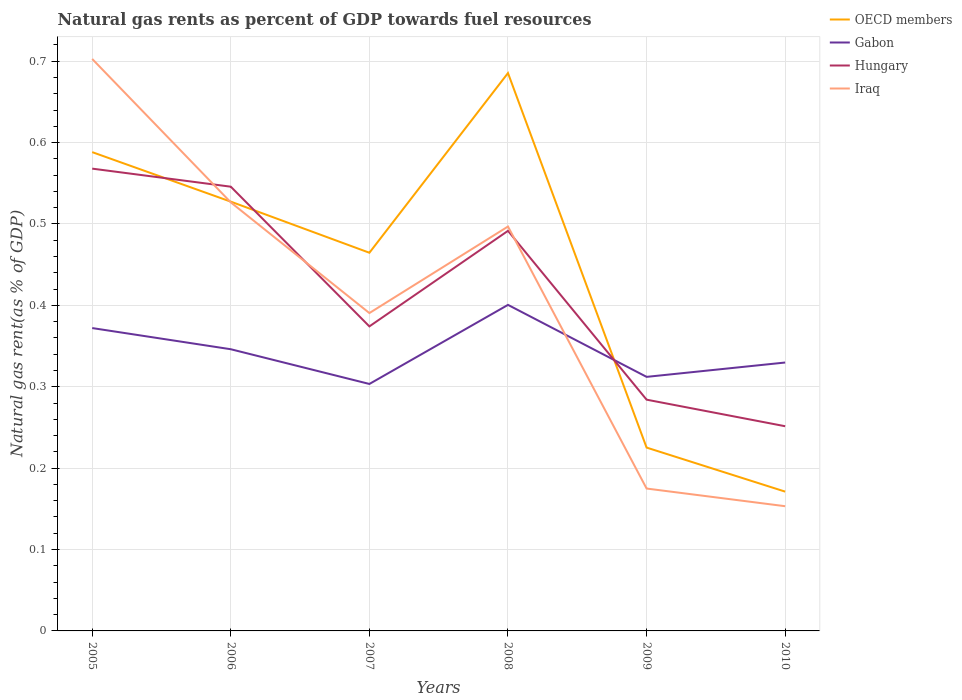How many different coloured lines are there?
Make the answer very short. 4. Is the number of lines equal to the number of legend labels?
Provide a short and direct response. Yes. Across all years, what is the maximum natural gas rent in Gabon?
Make the answer very short. 0.3. In which year was the natural gas rent in Gabon maximum?
Make the answer very short. 2007. What is the total natural gas rent in Gabon in the graph?
Offer a very short reply. 0.07. What is the difference between the highest and the second highest natural gas rent in Iraq?
Provide a succinct answer. 0.55. Is the natural gas rent in Hungary strictly greater than the natural gas rent in Iraq over the years?
Your answer should be compact. No. How many lines are there?
Make the answer very short. 4. How many years are there in the graph?
Your answer should be compact. 6. Are the values on the major ticks of Y-axis written in scientific E-notation?
Your answer should be compact. No. Does the graph contain any zero values?
Provide a succinct answer. No. Does the graph contain grids?
Offer a very short reply. Yes. What is the title of the graph?
Ensure brevity in your answer.  Natural gas rents as percent of GDP towards fuel resources. Does "Botswana" appear as one of the legend labels in the graph?
Make the answer very short. No. What is the label or title of the X-axis?
Your response must be concise. Years. What is the label or title of the Y-axis?
Give a very brief answer. Natural gas rent(as % of GDP). What is the Natural gas rent(as % of GDP) of OECD members in 2005?
Keep it short and to the point. 0.59. What is the Natural gas rent(as % of GDP) in Gabon in 2005?
Your response must be concise. 0.37. What is the Natural gas rent(as % of GDP) of Hungary in 2005?
Offer a very short reply. 0.57. What is the Natural gas rent(as % of GDP) in Iraq in 2005?
Provide a short and direct response. 0.7. What is the Natural gas rent(as % of GDP) of OECD members in 2006?
Give a very brief answer. 0.53. What is the Natural gas rent(as % of GDP) in Gabon in 2006?
Your response must be concise. 0.35. What is the Natural gas rent(as % of GDP) of Hungary in 2006?
Provide a short and direct response. 0.55. What is the Natural gas rent(as % of GDP) in Iraq in 2006?
Provide a short and direct response. 0.53. What is the Natural gas rent(as % of GDP) in OECD members in 2007?
Ensure brevity in your answer.  0.46. What is the Natural gas rent(as % of GDP) of Gabon in 2007?
Provide a short and direct response. 0.3. What is the Natural gas rent(as % of GDP) in Hungary in 2007?
Ensure brevity in your answer.  0.37. What is the Natural gas rent(as % of GDP) of Iraq in 2007?
Provide a succinct answer. 0.39. What is the Natural gas rent(as % of GDP) in OECD members in 2008?
Your response must be concise. 0.69. What is the Natural gas rent(as % of GDP) in Gabon in 2008?
Ensure brevity in your answer.  0.4. What is the Natural gas rent(as % of GDP) of Hungary in 2008?
Offer a terse response. 0.49. What is the Natural gas rent(as % of GDP) in Iraq in 2008?
Offer a very short reply. 0.5. What is the Natural gas rent(as % of GDP) of OECD members in 2009?
Your response must be concise. 0.23. What is the Natural gas rent(as % of GDP) in Gabon in 2009?
Provide a short and direct response. 0.31. What is the Natural gas rent(as % of GDP) of Hungary in 2009?
Offer a terse response. 0.28. What is the Natural gas rent(as % of GDP) in Iraq in 2009?
Provide a short and direct response. 0.17. What is the Natural gas rent(as % of GDP) in OECD members in 2010?
Your answer should be compact. 0.17. What is the Natural gas rent(as % of GDP) of Gabon in 2010?
Keep it short and to the point. 0.33. What is the Natural gas rent(as % of GDP) in Hungary in 2010?
Give a very brief answer. 0.25. What is the Natural gas rent(as % of GDP) of Iraq in 2010?
Your response must be concise. 0.15. Across all years, what is the maximum Natural gas rent(as % of GDP) of OECD members?
Your response must be concise. 0.69. Across all years, what is the maximum Natural gas rent(as % of GDP) of Gabon?
Offer a terse response. 0.4. Across all years, what is the maximum Natural gas rent(as % of GDP) in Hungary?
Offer a terse response. 0.57. Across all years, what is the maximum Natural gas rent(as % of GDP) of Iraq?
Your answer should be very brief. 0.7. Across all years, what is the minimum Natural gas rent(as % of GDP) in OECD members?
Provide a short and direct response. 0.17. Across all years, what is the minimum Natural gas rent(as % of GDP) in Gabon?
Provide a succinct answer. 0.3. Across all years, what is the minimum Natural gas rent(as % of GDP) of Hungary?
Provide a succinct answer. 0.25. Across all years, what is the minimum Natural gas rent(as % of GDP) of Iraq?
Make the answer very short. 0.15. What is the total Natural gas rent(as % of GDP) in OECD members in the graph?
Provide a succinct answer. 2.66. What is the total Natural gas rent(as % of GDP) in Gabon in the graph?
Ensure brevity in your answer.  2.06. What is the total Natural gas rent(as % of GDP) in Hungary in the graph?
Your answer should be very brief. 2.52. What is the total Natural gas rent(as % of GDP) in Iraq in the graph?
Ensure brevity in your answer.  2.44. What is the difference between the Natural gas rent(as % of GDP) in OECD members in 2005 and that in 2006?
Ensure brevity in your answer.  0.06. What is the difference between the Natural gas rent(as % of GDP) in Gabon in 2005 and that in 2006?
Give a very brief answer. 0.03. What is the difference between the Natural gas rent(as % of GDP) in Hungary in 2005 and that in 2006?
Ensure brevity in your answer.  0.02. What is the difference between the Natural gas rent(as % of GDP) of Iraq in 2005 and that in 2006?
Offer a terse response. 0.18. What is the difference between the Natural gas rent(as % of GDP) in OECD members in 2005 and that in 2007?
Offer a terse response. 0.12. What is the difference between the Natural gas rent(as % of GDP) of Gabon in 2005 and that in 2007?
Keep it short and to the point. 0.07. What is the difference between the Natural gas rent(as % of GDP) of Hungary in 2005 and that in 2007?
Keep it short and to the point. 0.19. What is the difference between the Natural gas rent(as % of GDP) in Iraq in 2005 and that in 2007?
Your response must be concise. 0.31. What is the difference between the Natural gas rent(as % of GDP) in OECD members in 2005 and that in 2008?
Offer a very short reply. -0.1. What is the difference between the Natural gas rent(as % of GDP) of Gabon in 2005 and that in 2008?
Give a very brief answer. -0.03. What is the difference between the Natural gas rent(as % of GDP) in Hungary in 2005 and that in 2008?
Make the answer very short. 0.08. What is the difference between the Natural gas rent(as % of GDP) of Iraq in 2005 and that in 2008?
Make the answer very short. 0.21. What is the difference between the Natural gas rent(as % of GDP) of OECD members in 2005 and that in 2009?
Your response must be concise. 0.36. What is the difference between the Natural gas rent(as % of GDP) in Hungary in 2005 and that in 2009?
Offer a very short reply. 0.28. What is the difference between the Natural gas rent(as % of GDP) of Iraq in 2005 and that in 2009?
Offer a terse response. 0.53. What is the difference between the Natural gas rent(as % of GDP) in OECD members in 2005 and that in 2010?
Offer a terse response. 0.42. What is the difference between the Natural gas rent(as % of GDP) of Gabon in 2005 and that in 2010?
Your response must be concise. 0.04. What is the difference between the Natural gas rent(as % of GDP) in Hungary in 2005 and that in 2010?
Make the answer very short. 0.32. What is the difference between the Natural gas rent(as % of GDP) of Iraq in 2005 and that in 2010?
Make the answer very short. 0.55. What is the difference between the Natural gas rent(as % of GDP) of OECD members in 2006 and that in 2007?
Your answer should be very brief. 0.06. What is the difference between the Natural gas rent(as % of GDP) of Gabon in 2006 and that in 2007?
Provide a succinct answer. 0.04. What is the difference between the Natural gas rent(as % of GDP) of Hungary in 2006 and that in 2007?
Provide a succinct answer. 0.17. What is the difference between the Natural gas rent(as % of GDP) in Iraq in 2006 and that in 2007?
Give a very brief answer. 0.14. What is the difference between the Natural gas rent(as % of GDP) in OECD members in 2006 and that in 2008?
Offer a terse response. -0.16. What is the difference between the Natural gas rent(as % of GDP) in Gabon in 2006 and that in 2008?
Keep it short and to the point. -0.05. What is the difference between the Natural gas rent(as % of GDP) of Hungary in 2006 and that in 2008?
Offer a terse response. 0.05. What is the difference between the Natural gas rent(as % of GDP) in Iraq in 2006 and that in 2008?
Give a very brief answer. 0.03. What is the difference between the Natural gas rent(as % of GDP) of OECD members in 2006 and that in 2009?
Offer a very short reply. 0.3. What is the difference between the Natural gas rent(as % of GDP) in Gabon in 2006 and that in 2009?
Give a very brief answer. 0.03. What is the difference between the Natural gas rent(as % of GDP) of Hungary in 2006 and that in 2009?
Offer a very short reply. 0.26. What is the difference between the Natural gas rent(as % of GDP) of Iraq in 2006 and that in 2009?
Ensure brevity in your answer.  0.35. What is the difference between the Natural gas rent(as % of GDP) in OECD members in 2006 and that in 2010?
Ensure brevity in your answer.  0.36. What is the difference between the Natural gas rent(as % of GDP) of Gabon in 2006 and that in 2010?
Your answer should be very brief. 0.02. What is the difference between the Natural gas rent(as % of GDP) in Hungary in 2006 and that in 2010?
Provide a short and direct response. 0.29. What is the difference between the Natural gas rent(as % of GDP) in Iraq in 2006 and that in 2010?
Your response must be concise. 0.37. What is the difference between the Natural gas rent(as % of GDP) of OECD members in 2007 and that in 2008?
Your response must be concise. -0.22. What is the difference between the Natural gas rent(as % of GDP) of Gabon in 2007 and that in 2008?
Give a very brief answer. -0.1. What is the difference between the Natural gas rent(as % of GDP) in Hungary in 2007 and that in 2008?
Provide a succinct answer. -0.12. What is the difference between the Natural gas rent(as % of GDP) of Iraq in 2007 and that in 2008?
Your answer should be compact. -0.11. What is the difference between the Natural gas rent(as % of GDP) in OECD members in 2007 and that in 2009?
Provide a succinct answer. 0.24. What is the difference between the Natural gas rent(as % of GDP) of Gabon in 2007 and that in 2009?
Your answer should be compact. -0.01. What is the difference between the Natural gas rent(as % of GDP) in Hungary in 2007 and that in 2009?
Offer a terse response. 0.09. What is the difference between the Natural gas rent(as % of GDP) in Iraq in 2007 and that in 2009?
Provide a short and direct response. 0.22. What is the difference between the Natural gas rent(as % of GDP) of OECD members in 2007 and that in 2010?
Ensure brevity in your answer.  0.29. What is the difference between the Natural gas rent(as % of GDP) in Gabon in 2007 and that in 2010?
Your response must be concise. -0.03. What is the difference between the Natural gas rent(as % of GDP) in Hungary in 2007 and that in 2010?
Keep it short and to the point. 0.12. What is the difference between the Natural gas rent(as % of GDP) of Iraq in 2007 and that in 2010?
Give a very brief answer. 0.24. What is the difference between the Natural gas rent(as % of GDP) in OECD members in 2008 and that in 2009?
Provide a succinct answer. 0.46. What is the difference between the Natural gas rent(as % of GDP) of Gabon in 2008 and that in 2009?
Your answer should be compact. 0.09. What is the difference between the Natural gas rent(as % of GDP) in Hungary in 2008 and that in 2009?
Make the answer very short. 0.21. What is the difference between the Natural gas rent(as % of GDP) of Iraq in 2008 and that in 2009?
Give a very brief answer. 0.32. What is the difference between the Natural gas rent(as % of GDP) of OECD members in 2008 and that in 2010?
Offer a very short reply. 0.51. What is the difference between the Natural gas rent(as % of GDP) of Gabon in 2008 and that in 2010?
Make the answer very short. 0.07. What is the difference between the Natural gas rent(as % of GDP) in Hungary in 2008 and that in 2010?
Your response must be concise. 0.24. What is the difference between the Natural gas rent(as % of GDP) of Iraq in 2008 and that in 2010?
Your response must be concise. 0.34. What is the difference between the Natural gas rent(as % of GDP) in OECD members in 2009 and that in 2010?
Make the answer very short. 0.05. What is the difference between the Natural gas rent(as % of GDP) of Gabon in 2009 and that in 2010?
Keep it short and to the point. -0.02. What is the difference between the Natural gas rent(as % of GDP) in Hungary in 2009 and that in 2010?
Your response must be concise. 0.03. What is the difference between the Natural gas rent(as % of GDP) of Iraq in 2009 and that in 2010?
Offer a terse response. 0.02. What is the difference between the Natural gas rent(as % of GDP) in OECD members in 2005 and the Natural gas rent(as % of GDP) in Gabon in 2006?
Give a very brief answer. 0.24. What is the difference between the Natural gas rent(as % of GDP) of OECD members in 2005 and the Natural gas rent(as % of GDP) of Hungary in 2006?
Provide a short and direct response. 0.04. What is the difference between the Natural gas rent(as % of GDP) of OECD members in 2005 and the Natural gas rent(as % of GDP) of Iraq in 2006?
Ensure brevity in your answer.  0.06. What is the difference between the Natural gas rent(as % of GDP) of Gabon in 2005 and the Natural gas rent(as % of GDP) of Hungary in 2006?
Your answer should be very brief. -0.17. What is the difference between the Natural gas rent(as % of GDP) of Gabon in 2005 and the Natural gas rent(as % of GDP) of Iraq in 2006?
Offer a terse response. -0.15. What is the difference between the Natural gas rent(as % of GDP) in Hungary in 2005 and the Natural gas rent(as % of GDP) in Iraq in 2006?
Ensure brevity in your answer.  0.04. What is the difference between the Natural gas rent(as % of GDP) in OECD members in 2005 and the Natural gas rent(as % of GDP) in Gabon in 2007?
Give a very brief answer. 0.28. What is the difference between the Natural gas rent(as % of GDP) of OECD members in 2005 and the Natural gas rent(as % of GDP) of Hungary in 2007?
Provide a succinct answer. 0.21. What is the difference between the Natural gas rent(as % of GDP) in OECD members in 2005 and the Natural gas rent(as % of GDP) in Iraq in 2007?
Provide a succinct answer. 0.2. What is the difference between the Natural gas rent(as % of GDP) of Gabon in 2005 and the Natural gas rent(as % of GDP) of Hungary in 2007?
Ensure brevity in your answer.  -0. What is the difference between the Natural gas rent(as % of GDP) of Gabon in 2005 and the Natural gas rent(as % of GDP) of Iraq in 2007?
Provide a succinct answer. -0.02. What is the difference between the Natural gas rent(as % of GDP) of Hungary in 2005 and the Natural gas rent(as % of GDP) of Iraq in 2007?
Provide a short and direct response. 0.18. What is the difference between the Natural gas rent(as % of GDP) in OECD members in 2005 and the Natural gas rent(as % of GDP) in Gabon in 2008?
Your answer should be compact. 0.19. What is the difference between the Natural gas rent(as % of GDP) in OECD members in 2005 and the Natural gas rent(as % of GDP) in Hungary in 2008?
Your response must be concise. 0.1. What is the difference between the Natural gas rent(as % of GDP) in OECD members in 2005 and the Natural gas rent(as % of GDP) in Iraq in 2008?
Provide a succinct answer. 0.09. What is the difference between the Natural gas rent(as % of GDP) in Gabon in 2005 and the Natural gas rent(as % of GDP) in Hungary in 2008?
Your response must be concise. -0.12. What is the difference between the Natural gas rent(as % of GDP) of Gabon in 2005 and the Natural gas rent(as % of GDP) of Iraq in 2008?
Your answer should be very brief. -0.12. What is the difference between the Natural gas rent(as % of GDP) of Hungary in 2005 and the Natural gas rent(as % of GDP) of Iraq in 2008?
Keep it short and to the point. 0.07. What is the difference between the Natural gas rent(as % of GDP) of OECD members in 2005 and the Natural gas rent(as % of GDP) of Gabon in 2009?
Keep it short and to the point. 0.28. What is the difference between the Natural gas rent(as % of GDP) in OECD members in 2005 and the Natural gas rent(as % of GDP) in Hungary in 2009?
Ensure brevity in your answer.  0.3. What is the difference between the Natural gas rent(as % of GDP) of OECD members in 2005 and the Natural gas rent(as % of GDP) of Iraq in 2009?
Your answer should be very brief. 0.41. What is the difference between the Natural gas rent(as % of GDP) of Gabon in 2005 and the Natural gas rent(as % of GDP) of Hungary in 2009?
Your response must be concise. 0.09. What is the difference between the Natural gas rent(as % of GDP) of Gabon in 2005 and the Natural gas rent(as % of GDP) of Iraq in 2009?
Your answer should be very brief. 0.2. What is the difference between the Natural gas rent(as % of GDP) of Hungary in 2005 and the Natural gas rent(as % of GDP) of Iraq in 2009?
Make the answer very short. 0.39. What is the difference between the Natural gas rent(as % of GDP) in OECD members in 2005 and the Natural gas rent(as % of GDP) in Gabon in 2010?
Make the answer very short. 0.26. What is the difference between the Natural gas rent(as % of GDP) of OECD members in 2005 and the Natural gas rent(as % of GDP) of Hungary in 2010?
Your answer should be very brief. 0.34. What is the difference between the Natural gas rent(as % of GDP) in OECD members in 2005 and the Natural gas rent(as % of GDP) in Iraq in 2010?
Provide a short and direct response. 0.43. What is the difference between the Natural gas rent(as % of GDP) of Gabon in 2005 and the Natural gas rent(as % of GDP) of Hungary in 2010?
Keep it short and to the point. 0.12. What is the difference between the Natural gas rent(as % of GDP) of Gabon in 2005 and the Natural gas rent(as % of GDP) of Iraq in 2010?
Your answer should be very brief. 0.22. What is the difference between the Natural gas rent(as % of GDP) of Hungary in 2005 and the Natural gas rent(as % of GDP) of Iraq in 2010?
Keep it short and to the point. 0.41. What is the difference between the Natural gas rent(as % of GDP) of OECD members in 2006 and the Natural gas rent(as % of GDP) of Gabon in 2007?
Ensure brevity in your answer.  0.22. What is the difference between the Natural gas rent(as % of GDP) of OECD members in 2006 and the Natural gas rent(as % of GDP) of Hungary in 2007?
Your answer should be very brief. 0.15. What is the difference between the Natural gas rent(as % of GDP) in OECD members in 2006 and the Natural gas rent(as % of GDP) in Iraq in 2007?
Give a very brief answer. 0.14. What is the difference between the Natural gas rent(as % of GDP) in Gabon in 2006 and the Natural gas rent(as % of GDP) in Hungary in 2007?
Your answer should be compact. -0.03. What is the difference between the Natural gas rent(as % of GDP) of Gabon in 2006 and the Natural gas rent(as % of GDP) of Iraq in 2007?
Make the answer very short. -0.04. What is the difference between the Natural gas rent(as % of GDP) in Hungary in 2006 and the Natural gas rent(as % of GDP) in Iraq in 2007?
Give a very brief answer. 0.16. What is the difference between the Natural gas rent(as % of GDP) in OECD members in 2006 and the Natural gas rent(as % of GDP) in Gabon in 2008?
Ensure brevity in your answer.  0.13. What is the difference between the Natural gas rent(as % of GDP) of OECD members in 2006 and the Natural gas rent(as % of GDP) of Hungary in 2008?
Keep it short and to the point. 0.04. What is the difference between the Natural gas rent(as % of GDP) in OECD members in 2006 and the Natural gas rent(as % of GDP) in Iraq in 2008?
Provide a succinct answer. 0.03. What is the difference between the Natural gas rent(as % of GDP) of Gabon in 2006 and the Natural gas rent(as % of GDP) of Hungary in 2008?
Keep it short and to the point. -0.15. What is the difference between the Natural gas rent(as % of GDP) in Gabon in 2006 and the Natural gas rent(as % of GDP) in Iraq in 2008?
Keep it short and to the point. -0.15. What is the difference between the Natural gas rent(as % of GDP) of Hungary in 2006 and the Natural gas rent(as % of GDP) of Iraq in 2008?
Provide a short and direct response. 0.05. What is the difference between the Natural gas rent(as % of GDP) in OECD members in 2006 and the Natural gas rent(as % of GDP) in Gabon in 2009?
Offer a terse response. 0.22. What is the difference between the Natural gas rent(as % of GDP) in OECD members in 2006 and the Natural gas rent(as % of GDP) in Hungary in 2009?
Keep it short and to the point. 0.24. What is the difference between the Natural gas rent(as % of GDP) in OECD members in 2006 and the Natural gas rent(as % of GDP) in Iraq in 2009?
Give a very brief answer. 0.35. What is the difference between the Natural gas rent(as % of GDP) of Gabon in 2006 and the Natural gas rent(as % of GDP) of Hungary in 2009?
Provide a short and direct response. 0.06. What is the difference between the Natural gas rent(as % of GDP) of Gabon in 2006 and the Natural gas rent(as % of GDP) of Iraq in 2009?
Your answer should be compact. 0.17. What is the difference between the Natural gas rent(as % of GDP) in Hungary in 2006 and the Natural gas rent(as % of GDP) in Iraq in 2009?
Give a very brief answer. 0.37. What is the difference between the Natural gas rent(as % of GDP) of OECD members in 2006 and the Natural gas rent(as % of GDP) of Gabon in 2010?
Give a very brief answer. 0.2. What is the difference between the Natural gas rent(as % of GDP) in OECD members in 2006 and the Natural gas rent(as % of GDP) in Hungary in 2010?
Your answer should be compact. 0.28. What is the difference between the Natural gas rent(as % of GDP) of OECD members in 2006 and the Natural gas rent(as % of GDP) of Iraq in 2010?
Offer a terse response. 0.37. What is the difference between the Natural gas rent(as % of GDP) of Gabon in 2006 and the Natural gas rent(as % of GDP) of Hungary in 2010?
Provide a succinct answer. 0.09. What is the difference between the Natural gas rent(as % of GDP) in Gabon in 2006 and the Natural gas rent(as % of GDP) in Iraq in 2010?
Your response must be concise. 0.19. What is the difference between the Natural gas rent(as % of GDP) in Hungary in 2006 and the Natural gas rent(as % of GDP) in Iraq in 2010?
Provide a succinct answer. 0.39. What is the difference between the Natural gas rent(as % of GDP) of OECD members in 2007 and the Natural gas rent(as % of GDP) of Gabon in 2008?
Make the answer very short. 0.06. What is the difference between the Natural gas rent(as % of GDP) of OECD members in 2007 and the Natural gas rent(as % of GDP) of Hungary in 2008?
Provide a succinct answer. -0.03. What is the difference between the Natural gas rent(as % of GDP) in OECD members in 2007 and the Natural gas rent(as % of GDP) in Iraq in 2008?
Give a very brief answer. -0.03. What is the difference between the Natural gas rent(as % of GDP) in Gabon in 2007 and the Natural gas rent(as % of GDP) in Hungary in 2008?
Provide a succinct answer. -0.19. What is the difference between the Natural gas rent(as % of GDP) of Gabon in 2007 and the Natural gas rent(as % of GDP) of Iraq in 2008?
Keep it short and to the point. -0.19. What is the difference between the Natural gas rent(as % of GDP) in Hungary in 2007 and the Natural gas rent(as % of GDP) in Iraq in 2008?
Your answer should be compact. -0.12. What is the difference between the Natural gas rent(as % of GDP) of OECD members in 2007 and the Natural gas rent(as % of GDP) of Gabon in 2009?
Your answer should be compact. 0.15. What is the difference between the Natural gas rent(as % of GDP) of OECD members in 2007 and the Natural gas rent(as % of GDP) of Hungary in 2009?
Offer a very short reply. 0.18. What is the difference between the Natural gas rent(as % of GDP) in OECD members in 2007 and the Natural gas rent(as % of GDP) in Iraq in 2009?
Provide a short and direct response. 0.29. What is the difference between the Natural gas rent(as % of GDP) of Gabon in 2007 and the Natural gas rent(as % of GDP) of Hungary in 2009?
Give a very brief answer. 0.02. What is the difference between the Natural gas rent(as % of GDP) in Gabon in 2007 and the Natural gas rent(as % of GDP) in Iraq in 2009?
Provide a succinct answer. 0.13. What is the difference between the Natural gas rent(as % of GDP) in Hungary in 2007 and the Natural gas rent(as % of GDP) in Iraq in 2009?
Provide a succinct answer. 0.2. What is the difference between the Natural gas rent(as % of GDP) in OECD members in 2007 and the Natural gas rent(as % of GDP) in Gabon in 2010?
Your answer should be compact. 0.13. What is the difference between the Natural gas rent(as % of GDP) in OECD members in 2007 and the Natural gas rent(as % of GDP) in Hungary in 2010?
Give a very brief answer. 0.21. What is the difference between the Natural gas rent(as % of GDP) in OECD members in 2007 and the Natural gas rent(as % of GDP) in Iraq in 2010?
Your answer should be compact. 0.31. What is the difference between the Natural gas rent(as % of GDP) in Gabon in 2007 and the Natural gas rent(as % of GDP) in Hungary in 2010?
Give a very brief answer. 0.05. What is the difference between the Natural gas rent(as % of GDP) in Gabon in 2007 and the Natural gas rent(as % of GDP) in Iraq in 2010?
Offer a terse response. 0.15. What is the difference between the Natural gas rent(as % of GDP) in Hungary in 2007 and the Natural gas rent(as % of GDP) in Iraq in 2010?
Your response must be concise. 0.22. What is the difference between the Natural gas rent(as % of GDP) in OECD members in 2008 and the Natural gas rent(as % of GDP) in Gabon in 2009?
Ensure brevity in your answer.  0.37. What is the difference between the Natural gas rent(as % of GDP) in OECD members in 2008 and the Natural gas rent(as % of GDP) in Hungary in 2009?
Keep it short and to the point. 0.4. What is the difference between the Natural gas rent(as % of GDP) of OECD members in 2008 and the Natural gas rent(as % of GDP) of Iraq in 2009?
Your answer should be very brief. 0.51. What is the difference between the Natural gas rent(as % of GDP) of Gabon in 2008 and the Natural gas rent(as % of GDP) of Hungary in 2009?
Offer a very short reply. 0.12. What is the difference between the Natural gas rent(as % of GDP) of Gabon in 2008 and the Natural gas rent(as % of GDP) of Iraq in 2009?
Provide a succinct answer. 0.23. What is the difference between the Natural gas rent(as % of GDP) in Hungary in 2008 and the Natural gas rent(as % of GDP) in Iraq in 2009?
Your answer should be compact. 0.32. What is the difference between the Natural gas rent(as % of GDP) in OECD members in 2008 and the Natural gas rent(as % of GDP) in Gabon in 2010?
Your response must be concise. 0.36. What is the difference between the Natural gas rent(as % of GDP) of OECD members in 2008 and the Natural gas rent(as % of GDP) of Hungary in 2010?
Offer a very short reply. 0.43. What is the difference between the Natural gas rent(as % of GDP) in OECD members in 2008 and the Natural gas rent(as % of GDP) in Iraq in 2010?
Provide a short and direct response. 0.53. What is the difference between the Natural gas rent(as % of GDP) of Gabon in 2008 and the Natural gas rent(as % of GDP) of Hungary in 2010?
Offer a terse response. 0.15. What is the difference between the Natural gas rent(as % of GDP) of Gabon in 2008 and the Natural gas rent(as % of GDP) of Iraq in 2010?
Provide a succinct answer. 0.25. What is the difference between the Natural gas rent(as % of GDP) of Hungary in 2008 and the Natural gas rent(as % of GDP) of Iraq in 2010?
Offer a terse response. 0.34. What is the difference between the Natural gas rent(as % of GDP) in OECD members in 2009 and the Natural gas rent(as % of GDP) in Gabon in 2010?
Ensure brevity in your answer.  -0.1. What is the difference between the Natural gas rent(as % of GDP) in OECD members in 2009 and the Natural gas rent(as % of GDP) in Hungary in 2010?
Your response must be concise. -0.03. What is the difference between the Natural gas rent(as % of GDP) of OECD members in 2009 and the Natural gas rent(as % of GDP) of Iraq in 2010?
Your answer should be very brief. 0.07. What is the difference between the Natural gas rent(as % of GDP) in Gabon in 2009 and the Natural gas rent(as % of GDP) in Hungary in 2010?
Your answer should be very brief. 0.06. What is the difference between the Natural gas rent(as % of GDP) of Gabon in 2009 and the Natural gas rent(as % of GDP) of Iraq in 2010?
Keep it short and to the point. 0.16. What is the difference between the Natural gas rent(as % of GDP) in Hungary in 2009 and the Natural gas rent(as % of GDP) in Iraq in 2010?
Give a very brief answer. 0.13. What is the average Natural gas rent(as % of GDP) of OECD members per year?
Provide a short and direct response. 0.44. What is the average Natural gas rent(as % of GDP) in Gabon per year?
Ensure brevity in your answer.  0.34. What is the average Natural gas rent(as % of GDP) in Hungary per year?
Make the answer very short. 0.42. What is the average Natural gas rent(as % of GDP) in Iraq per year?
Make the answer very short. 0.41. In the year 2005, what is the difference between the Natural gas rent(as % of GDP) of OECD members and Natural gas rent(as % of GDP) of Gabon?
Offer a very short reply. 0.22. In the year 2005, what is the difference between the Natural gas rent(as % of GDP) in OECD members and Natural gas rent(as % of GDP) in Hungary?
Your answer should be very brief. 0.02. In the year 2005, what is the difference between the Natural gas rent(as % of GDP) of OECD members and Natural gas rent(as % of GDP) of Iraq?
Keep it short and to the point. -0.11. In the year 2005, what is the difference between the Natural gas rent(as % of GDP) of Gabon and Natural gas rent(as % of GDP) of Hungary?
Ensure brevity in your answer.  -0.2. In the year 2005, what is the difference between the Natural gas rent(as % of GDP) of Gabon and Natural gas rent(as % of GDP) of Iraq?
Offer a very short reply. -0.33. In the year 2005, what is the difference between the Natural gas rent(as % of GDP) of Hungary and Natural gas rent(as % of GDP) of Iraq?
Make the answer very short. -0.13. In the year 2006, what is the difference between the Natural gas rent(as % of GDP) in OECD members and Natural gas rent(as % of GDP) in Gabon?
Your answer should be compact. 0.18. In the year 2006, what is the difference between the Natural gas rent(as % of GDP) of OECD members and Natural gas rent(as % of GDP) of Hungary?
Your answer should be compact. -0.02. In the year 2006, what is the difference between the Natural gas rent(as % of GDP) in OECD members and Natural gas rent(as % of GDP) in Iraq?
Make the answer very short. 0. In the year 2006, what is the difference between the Natural gas rent(as % of GDP) in Gabon and Natural gas rent(as % of GDP) in Hungary?
Keep it short and to the point. -0.2. In the year 2006, what is the difference between the Natural gas rent(as % of GDP) in Gabon and Natural gas rent(as % of GDP) in Iraq?
Provide a succinct answer. -0.18. In the year 2006, what is the difference between the Natural gas rent(as % of GDP) of Hungary and Natural gas rent(as % of GDP) of Iraq?
Offer a terse response. 0.02. In the year 2007, what is the difference between the Natural gas rent(as % of GDP) of OECD members and Natural gas rent(as % of GDP) of Gabon?
Your response must be concise. 0.16. In the year 2007, what is the difference between the Natural gas rent(as % of GDP) of OECD members and Natural gas rent(as % of GDP) of Hungary?
Your answer should be compact. 0.09. In the year 2007, what is the difference between the Natural gas rent(as % of GDP) in OECD members and Natural gas rent(as % of GDP) in Iraq?
Keep it short and to the point. 0.07. In the year 2007, what is the difference between the Natural gas rent(as % of GDP) in Gabon and Natural gas rent(as % of GDP) in Hungary?
Offer a very short reply. -0.07. In the year 2007, what is the difference between the Natural gas rent(as % of GDP) of Gabon and Natural gas rent(as % of GDP) of Iraq?
Offer a very short reply. -0.09. In the year 2007, what is the difference between the Natural gas rent(as % of GDP) of Hungary and Natural gas rent(as % of GDP) of Iraq?
Keep it short and to the point. -0.02. In the year 2008, what is the difference between the Natural gas rent(as % of GDP) of OECD members and Natural gas rent(as % of GDP) of Gabon?
Your answer should be very brief. 0.28. In the year 2008, what is the difference between the Natural gas rent(as % of GDP) of OECD members and Natural gas rent(as % of GDP) of Hungary?
Provide a short and direct response. 0.19. In the year 2008, what is the difference between the Natural gas rent(as % of GDP) in OECD members and Natural gas rent(as % of GDP) in Iraq?
Make the answer very short. 0.19. In the year 2008, what is the difference between the Natural gas rent(as % of GDP) in Gabon and Natural gas rent(as % of GDP) in Hungary?
Give a very brief answer. -0.09. In the year 2008, what is the difference between the Natural gas rent(as % of GDP) of Gabon and Natural gas rent(as % of GDP) of Iraq?
Keep it short and to the point. -0.1. In the year 2008, what is the difference between the Natural gas rent(as % of GDP) in Hungary and Natural gas rent(as % of GDP) in Iraq?
Provide a short and direct response. -0.01. In the year 2009, what is the difference between the Natural gas rent(as % of GDP) of OECD members and Natural gas rent(as % of GDP) of Gabon?
Your answer should be very brief. -0.09. In the year 2009, what is the difference between the Natural gas rent(as % of GDP) of OECD members and Natural gas rent(as % of GDP) of Hungary?
Ensure brevity in your answer.  -0.06. In the year 2009, what is the difference between the Natural gas rent(as % of GDP) of OECD members and Natural gas rent(as % of GDP) of Iraq?
Provide a succinct answer. 0.05. In the year 2009, what is the difference between the Natural gas rent(as % of GDP) of Gabon and Natural gas rent(as % of GDP) of Hungary?
Your answer should be compact. 0.03. In the year 2009, what is the difference between the Natural gas rent(as % of GDP) in Gabon and Natural gas rent(as % of GDP) in Iraq?
Give a very brief answer. 0.14. In the year 2009, what is the difference between the Natural gas rent(as % of GDP) of Hungary and Natural gas rent(as % of GDP) of Iraq?
Offer a terse response. 0.11. In the year 2010, what is the difference between the Natural gas rent(as % of GDP) in OECD members and Natural gas rent(as % of GDP) in Gabon?
Offer a terse response. -0.16. In the year 2010, what is the difference between the Natural gas rent(as % of GDP) of OECD members and Natural gas rent(as % of GDP) of Hungary?
Your answer should be compact. -0.08. In the year 2010, what is the difference between the Natural gas rent(as % of GDP) of OECD members and Natural gas rent(as % of GDP) of Iraq?
Your answer should be very brief. 0.02. In the year 2010, what is the difference between the Natural gas rent(as % of GDP) in Gabon and Natural gas rent(as % of GDP) in Hungary?
Provide a succinct answer. 0.08. In the year 2010, what is the difference between the Natural gas rent(as % of GDP) in Gabon and Natural gas rent(as % of GDP) in Iraq?
Provide a short and direct response. 0.18. In the year 2010, what is the difference between the Natural gas rent(as % of GDP) of Hungary and Natural gas rent(as % of GDP) of Iraq?
Provide a succinct answer. 0.1. What is the ratio of the Natural gas rent(as % of GDP) in OECD members in 2005 to that in 2006?
Offer a terse response. 1.12. What is the ratio of the Natural gas rent(as % of GDP) in Gabon in 2005 to that in 2006?
Provide a succinct answer. 1.08. What is the ratio of the Natural gas rent(as % of GDP) of Hungary in 2005 to that in 2006?
Your response must be concise. 1.04. What is the ratio of the Natural gas rent(as % of GDP) of Iraq in 2005 to that in 2006?
Offer a terse response. 1.33. What is the ratio of the Natural gas rent(as % of GDP) of OECD members in 2005 to that in 2007?
Give a very brief answer. 1.27. What is the ratio of the Natural gas rent(as % of GDP) in Gabon in 2005 to that in 2007?
Offer a very short reply. 1.23. What is the ratio of the Natural gas rent(as % of GDP) of Hungary in 2005 to that in 2007?
Offer a very short reply. 1.52. What is the ratio of the Natural gas rent(as % of GDP) of Iraq in 2005 to that in 2007?
Offer a terse response. 1.8. What is the ratio of the Natural gas rent(as % of GDP) in OECD members in 2005 to that in 2008?
Ensure brevity in your answer.  0.86. What is the ratio of the Natural gas rent(as % of GDP) in Gabon in 2005 to that in 2008?
Your answer should be compact. 0.93. What is the ratio of the Natural gas rent(as % of GDP) of Hungary in 2005 to that in 2008?
Ensure brevity in your answer.  1.16. What is the ratio of the Natural gas rent(as % of GDP) of Iraq in 2005 to that in 2008?
Keep it short and to the point. 1.41. What is the ratio of the Natural gas rent(as % of GDP) in OECD members in 2005 to that in 2009?
Provide a succinct answer. 2.61. What is the ratio of the Natural gas rent(as % of GDP) of Gabon in 2005 to that in 2009?
Your response must be concise. 1.19. What is the ratio of the Natural gas rent(as % of GDP) in Hungary in 2005 to that in 2009?
Keep it short and to the point. 2. What is the ratio of the Natural gas rent(as % of GDP) of Iraq in 2005 to that in 2009?
Make the answer very short. 4.02. What is the ratio of the Natural gas rent(as % of GDP) in OECD members in 2005 to that in 2010?
Ensure brevity in your answer.  3.44. What is the ratio of the Natural gas rent(as % of GDP) of Gabon in 2005 to that in 2010?
Your answer should be compact. 1.13. What is the ratio of the Natural gas rent(as % of GDP) in Hungary in 2005 to that in 2010?
Offer a terse response. 2.26. What is the ratio of the Natural gas rent(as % of GDP) in Iraq in 2005 to that in 2010?
Keep it short and to the point. 4.59. What is the ratio of the Natural gas rent(as % of GDP) of OECD members in 2006 to that in 2007?
Provide a short and direct response. 1.14. What is the ratio of the Natural gas rent(as % of GDP) of Gabon in 2006 to that in 2007?
Provide a succinct answer. 1.14. What is the ratio of the Natural gas rent(as % of GDP) of Hungary in 2006 to that in 2007?
Provide a succinct answer. 1.46. What is the ratio of the Natural gas rent(as % of GDP) of Iraq in 2006 to that in 2007?
Your answer should be compact. 1.35. What is the ratio of the Natural gas rent(as % of GDP) in OECD members in 2006 to that in 2008?
Your response must be concise. 0.77. What is the ratio of the Natural gas rent(as % of GDP) of Gabon in 2006 to that in 2008?
Your answer should be very brief. 0.86. What is the ratio of the Natural gas rent(as % of GDP) in Hungary in 2006 to that in 2008?
Offer a terse response. 1.11. What is the ratio of the Natural gas rent(as % of GDP) of Iraq in 2006 to that in 2008?
Provide a short and direct response. 1.06. What is the ratio of the Natural gas rent(as % of GDP) of OECD members in 2006 to that in 2009?
Your response must be concise. 2.34. What is the ratio of the Natural gas rent(as % of GDP) of Gabon in 2006 to that in 2009?
Ensure brevity in your answer.  1.11. What is the ratio of the Natural gas rent(as % of GDP) of Hungary in 2006 to that in 2009?
Your response must be concise. 1.92. What is the ratio of the Natural gas rent(as % of GDP) in Iraq in 2006 to that in 2009?
Your answer should be compact. 3.01. What is the ratio of the Natural gas rent(as % of GDP) of OECD members in 2006 to that in 2010?
Your answer should be very brief. 3.08. What is the ratio of the Natural gas rent(as % of GDP) of Gabon in 2006 to that in 2010?
Make the answer very short. 1.05. What is the ratio of the Natural gas rent(as % of GDP) of Hungary in 2006 to that in 2010?
Provide a short and direct response. 2.17. What is the ratio of the Natural gas rent(as % of GDP) in Iraq in 2006 to that in 2010?
Provide a succinct answer. 3.44. What is the ratio of the Natural gas rent(as % of GDP) of OECD members in 2007 to that in 2008?
Ensure brevity in your answer.  0.68. What is the ratio of the Natural gas rent(as % of GDP) of Gabon in 2007 to that in 2008?
Provide a short and direct response. 0.76. What is the ratio of the Natural gas rent(as % of GDP) in Hungary in 2007 to that in 2008?
Your answer should be compact. 0.76. What is the ratio of the Natural gas rent(as % of GDP) of Iraq in 2007 to that in 2008?
Offer a terse response. 0.79. What is the ratio of the Natural gas rent(as % of GDP) in OECD members in 2007 to that in 2009?
Provide a short and direct response. 2.06. What is the ratio of the Natural gas rent(as % of GDP) of Gabon in 2007 to that in 2009?
Ensure brevity in your answer.  0.97. What is the ratio of the Natural gas rent(as % of GDP) of Hungary in 2007 to that in 2009?
Offer a terse response. 1.32. What is the ratio of the Natural gas rent(as % of GDP) of Iraq in 2007 to that in 2009?
Make the answer very short. 2.23. What is the ratio of the Natural gas rent(as % of GDP) of OECD members in 2007 to that in 2010?
Keep it short and to the point. 2.71. What is the ratio of the Natural gas rent(as % of GDP) in Gabon in 2007 to that in 2010?
Your answer should be compact. 0.92. What is the ratio of the Natural gas rent(as % of GDP) of Hungary in 2007 to that in 2010?
Make the answer very short. 1.49. What is the ratio of the Natural gas rent(as % of GDP) of Iraq in 2007 to that in 2010?
Provide a short and direct response. 2.55. What is the ratio of the Natural gas rent(as % of GDP) in OECD members in 2008 to that in 2009?
Ensure brevity in your answer.  3.04. What is the ratio of the Natural gas rent(as % of GDP) in Gabon in 2008 to that in 2009?
Offer a very short reply. 1.28. What is the ratio of the Natural gas rent(as % of GDP) of Hungary in 2008 to that in 2009?
Keep it short and to the point. 1.73. What is the ratio of the Natural gas rent(as % of GDP) of Iraq in 2008 to that in 2009?
Ensure brevity in your answer.  2.84. What is the ratio of the Natural gas rent(as % of GDP) of OECD members in 2008 to that in 2010?
Offer a very short reply. 4. What is the ratio of the Natural gas rent(as % of GDP) of Gabon in 2008 to that in 2010?
Your answer should be compact. 1.21. What is the ratio of the Natural gas rent(as % of GDP) in Hungary in 2008 to that in 2010?
Your answer should be very brief. 1.95. What is the ratio of the Natural gas rent(as % of GDP) of Iraq in 2008 to that in 2010?
Offer a very short reply. 3.24. What is the ratio of the Natural gas rent(as % of GDP) of OECD members in 2009 to that in 2010?
Your response must be concise. 1.32. What is the ratio of the Natural gas rent(as % of GDP) in Gabon in 2009 to that in 2010?
Your answer should be very brief. 0.95. What is the ratio of the Natural gas rent(as % of GDP) of Hungary in 2009 to that in 2010?
Your answer should be very brief. 1.13. What is the ratio of the Natural gas rent(as % of GDP) of Iraq in 2009 to that in 2010?
Make the answer very short. 1.14. What is the difference between the highest and the second highest Natural gas rent(as % of GDP) in OECD members?
Offer a very short reply. 0.1. What is the difference between the highest and the second highest Natural gas rent(as % of GDP) in Gabon?
Give a very brief answer. 0.03. What is the difference between the highest and the second highest Natural gas rent(as % of GDP) in Hungary?
Keep it short and to the point. 0.02. What is the difference between the highest and the second highest Natural gas rent(as % of GDP) in Iraq?
Provide a succinct answer. 0.18. What is the difference between the highest and the lowest Natural gas rent(as % of GDP) of OECD members?
Offer a terse response. 0.51. What is the difference between the highest and the lowest Natural gas rent(as % of GDP) of Gabon?
Make the answer very short. 0.1. What is the difference between the highest and the lowest Natural gas rent(as % of GDP) of Hungary?
Your response must be concise. 0.32. What is the difference between the highest and the lowest Natural gas rent(as % of GDP) of Iraq?
Provide a short and direct response. 0.55. 